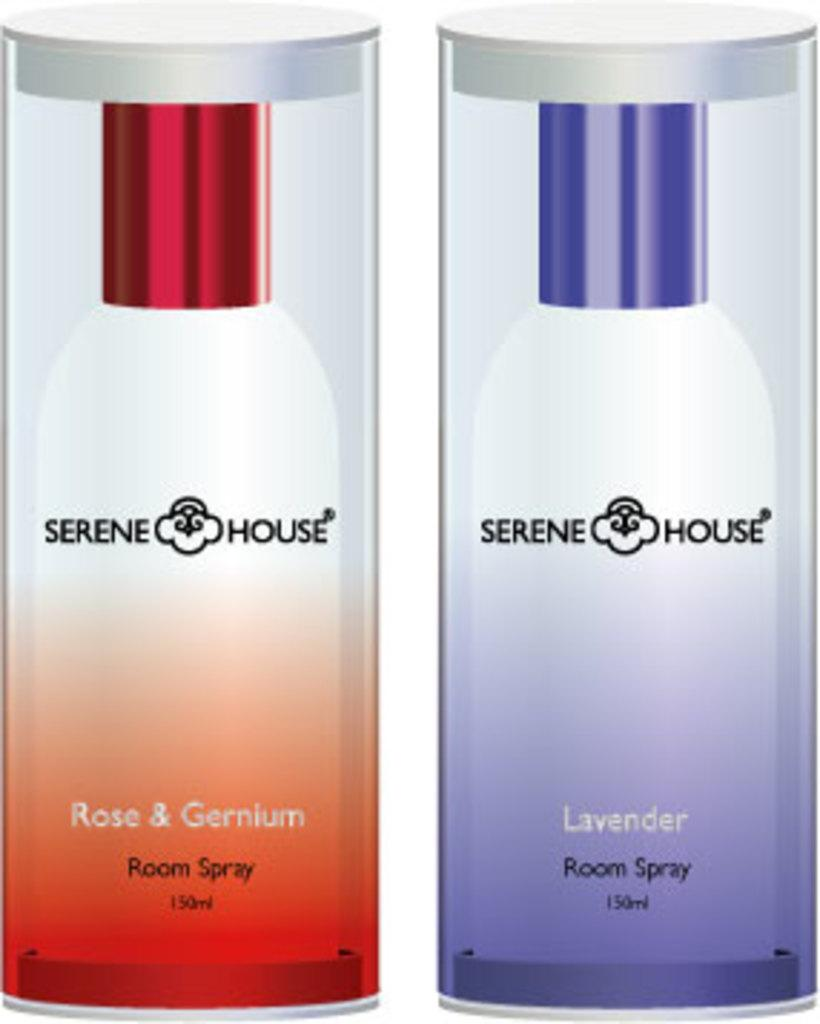<image>
Render a clear and concise summary of the photo. Two different scents of Serene House room spray are next to each other. 